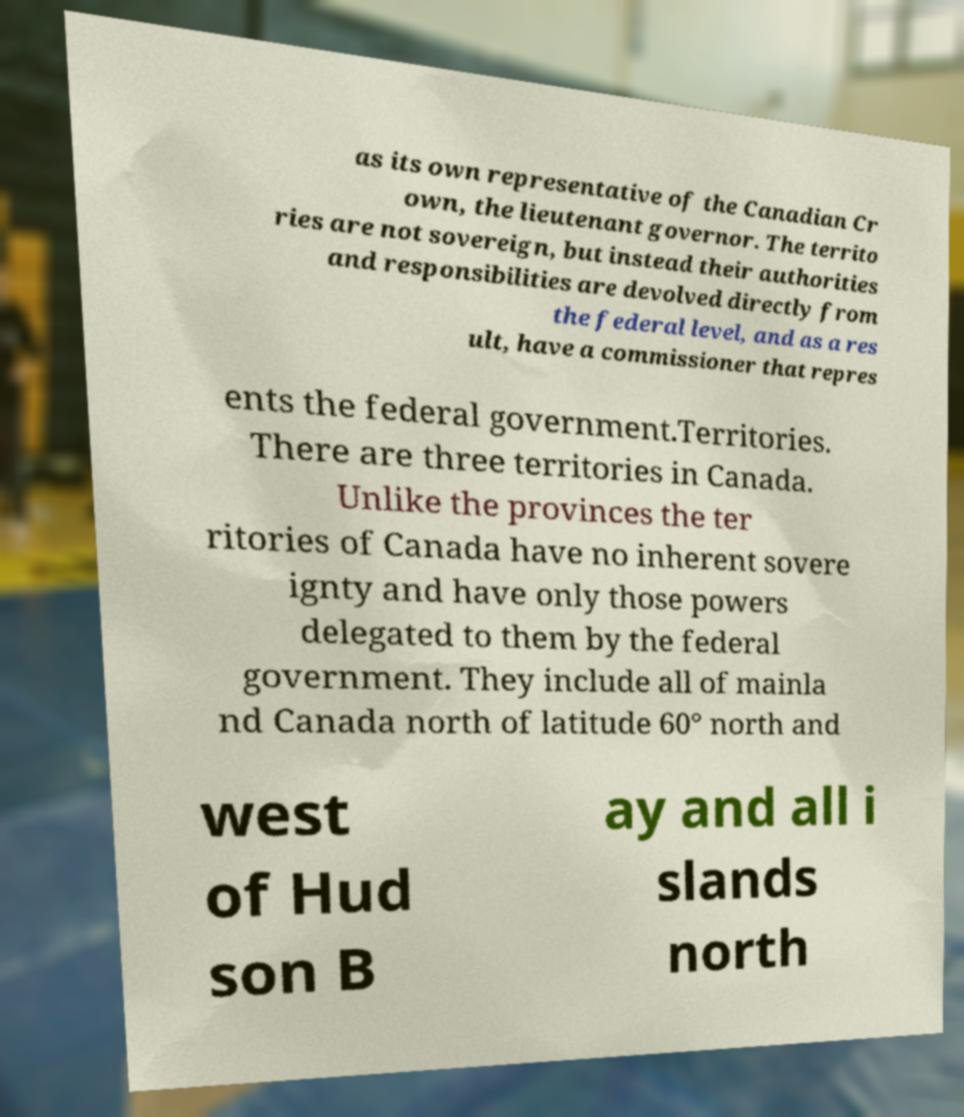Can you read and provide the text displayed in the image?This photo seems to have some interesting text. Can you extract and type it out for me? as its own representative of the Canadian Cr own, the lieutenant governor. The territo ries are not sovereign, but instead their authorities and responsibilities are devolved directly from the federal level, and as a res ult, have a commissioner that repres ents the federal government.Territories. There are three territories in Canada. Unlike the provinces the ter ritories of Canada have no inherent sovere ignty and have only those powers delegated to them by the federal government. They include all of mainla nd Canada north of latitude 60° north and west of Hud son B ay and all i slands north 